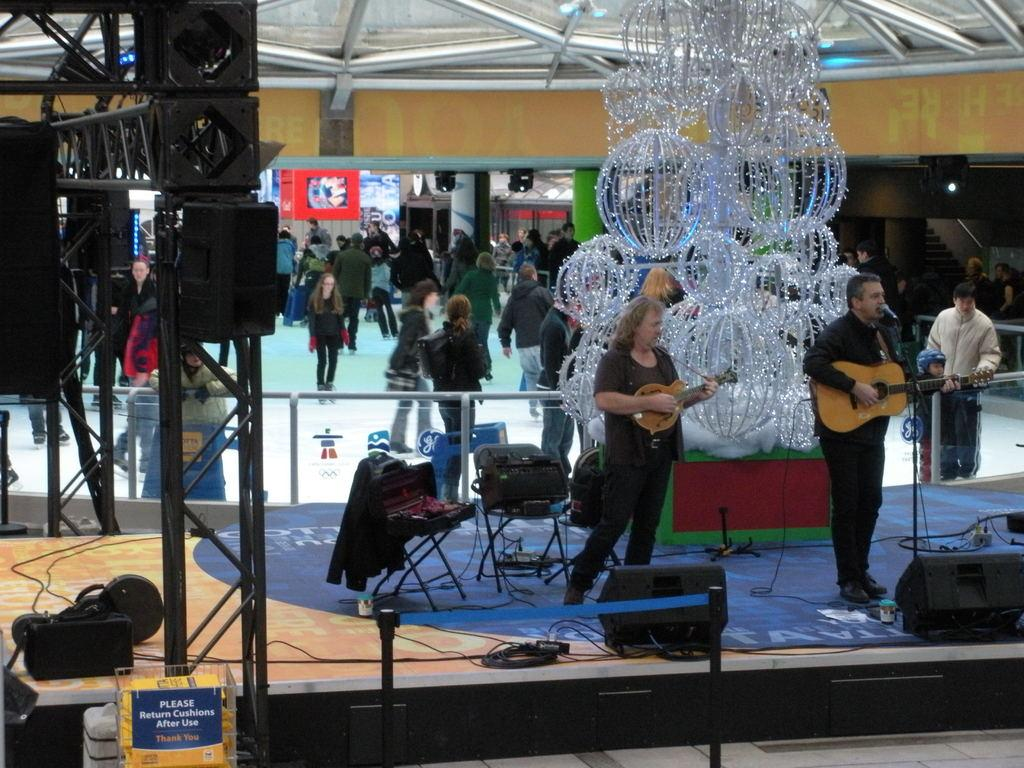How many people are performing in the image? There are two people in the image. What are the two people doing? The two people are singing and playing the guitar. Where is the scene taking place? The scene takes place inside a mall. Can you describe the background of the image? There are a few people walking in the background. What type of machine can be seen in the image? A: There is no machine present in the image. How does the singing affect the people walking in the background? The image does not show any effect on the people walking in the background; it only shows them walking. 